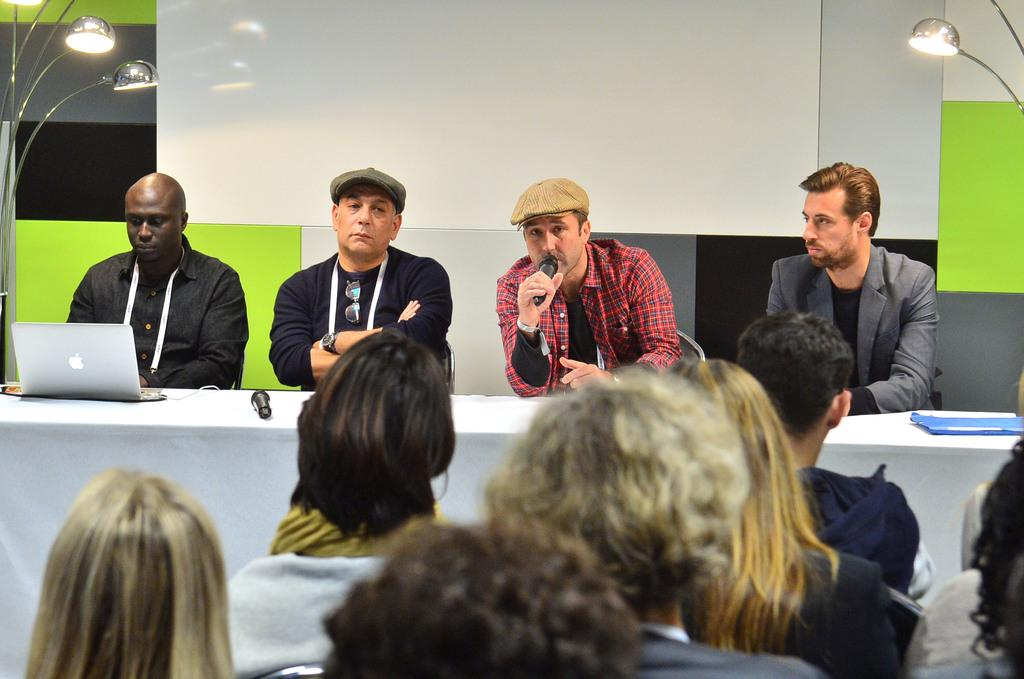What is the person wearing in the image? The person is wearing red in the image. What is the person wearing red doing? The person wearing red is sitting and speaking in front of a mic. Are there other people present in the image? Yes, there are other people sitting beside the person wearing red, and a group of people is in front of them. What type of crack is visible in the image? There is no crack visible in the image. Is the image taken in a circular room? The shape of the room is not mentioned in the provided facts, so it cannot be determined from the image. 